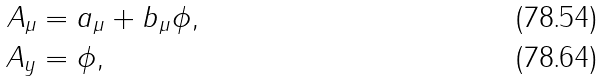Convert formula to latex. <formula><loc_0><loc_0><loc_500><loc_500>A _ { \mu } & = a _ { \mu } + b _ { \mu } \phi , \\ A _ { y } & = \phi ,</formula> 